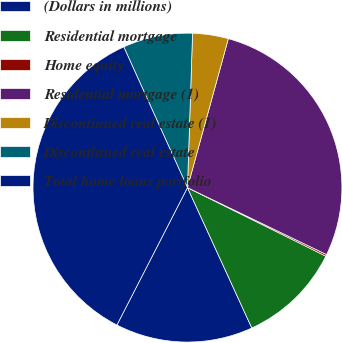<chart> <loc_0><loc_0><loc_500><loc_500><pie_chart><fcel>(Dollars in millions)<fcel>Residential mortgage<fcel>Home equity<fcel>Residential mortgage (1)<fcel>Discontinued real estate (1)<fcel>Discontinued real estate<fcel>Total home loans portfolio<nl><fcel>14.39%<fcel>10.84%<fcel>0.18%<fcel>27.88%<fcel>3.74%<fcel>7.29%<fcel>35.69%<nl></chart> 